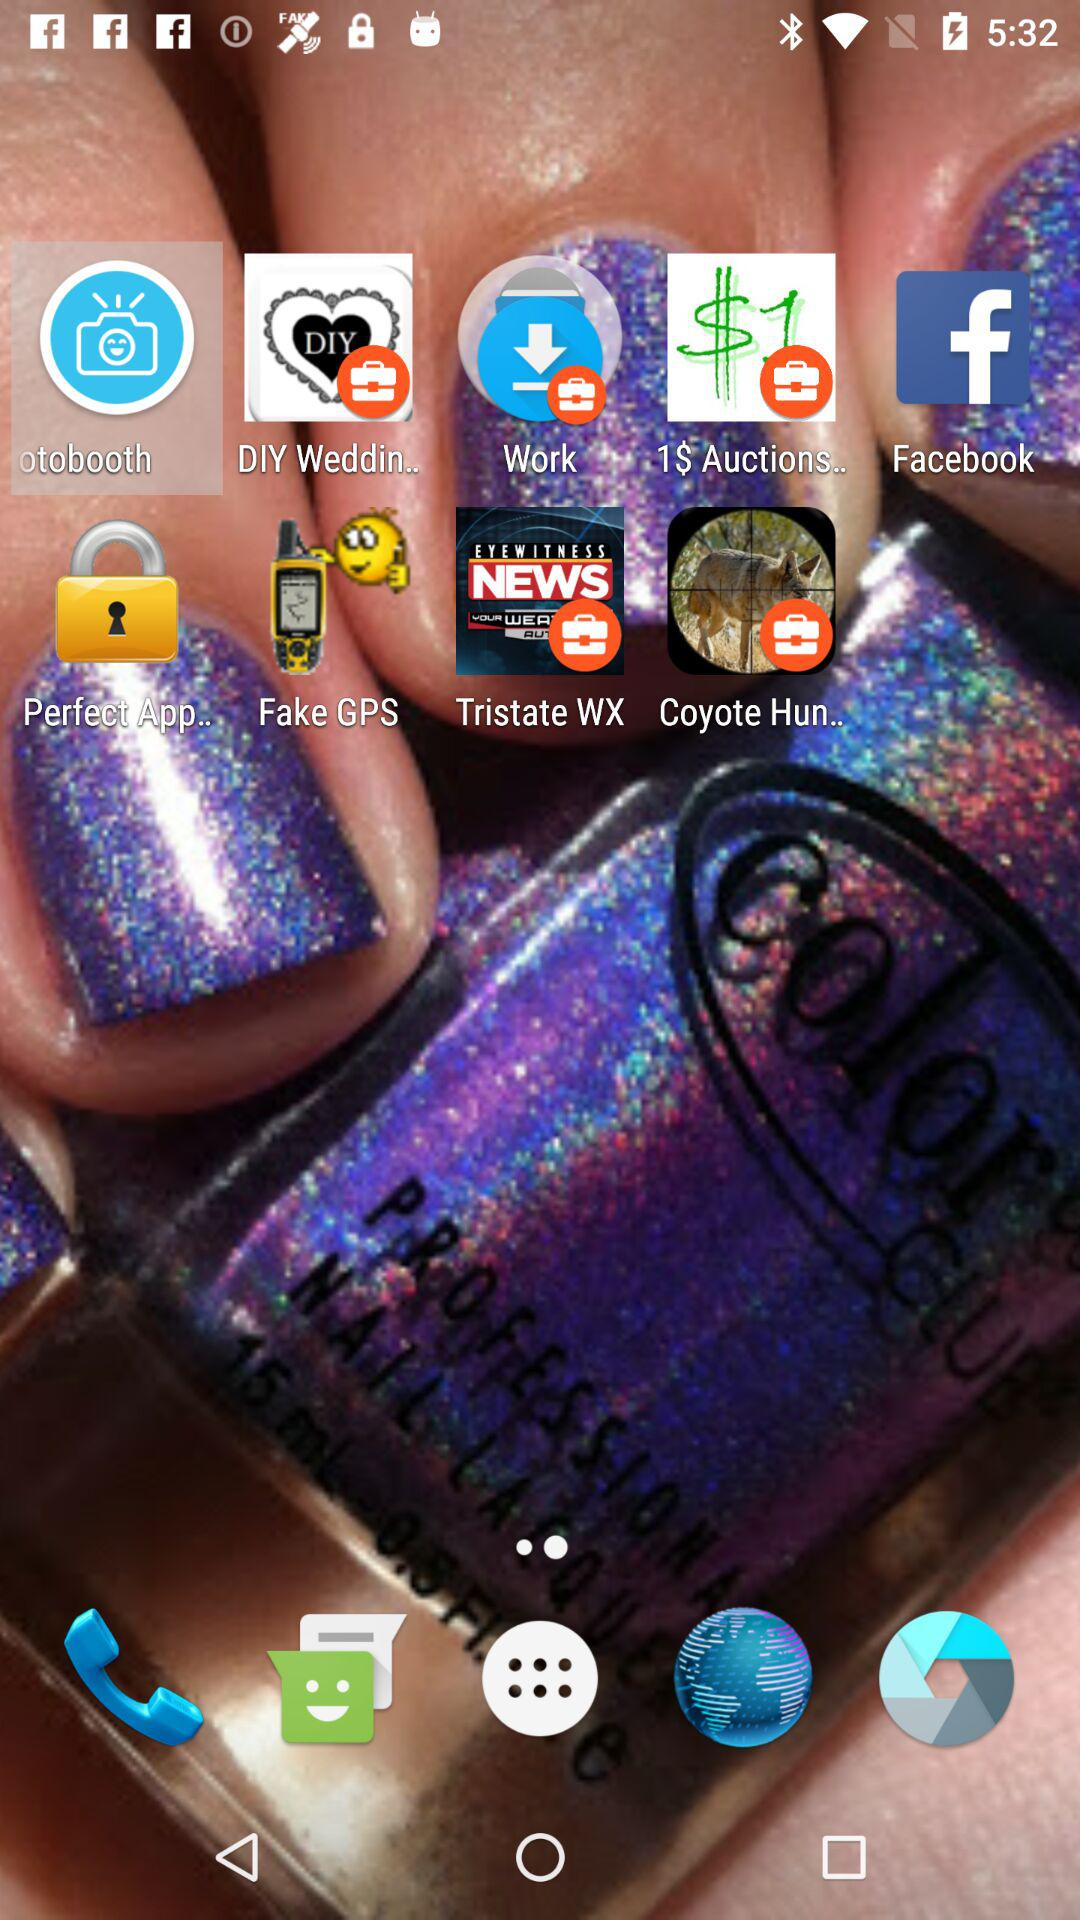What is the application name? The application name is "APEX PREDATOR PROTECTION". 